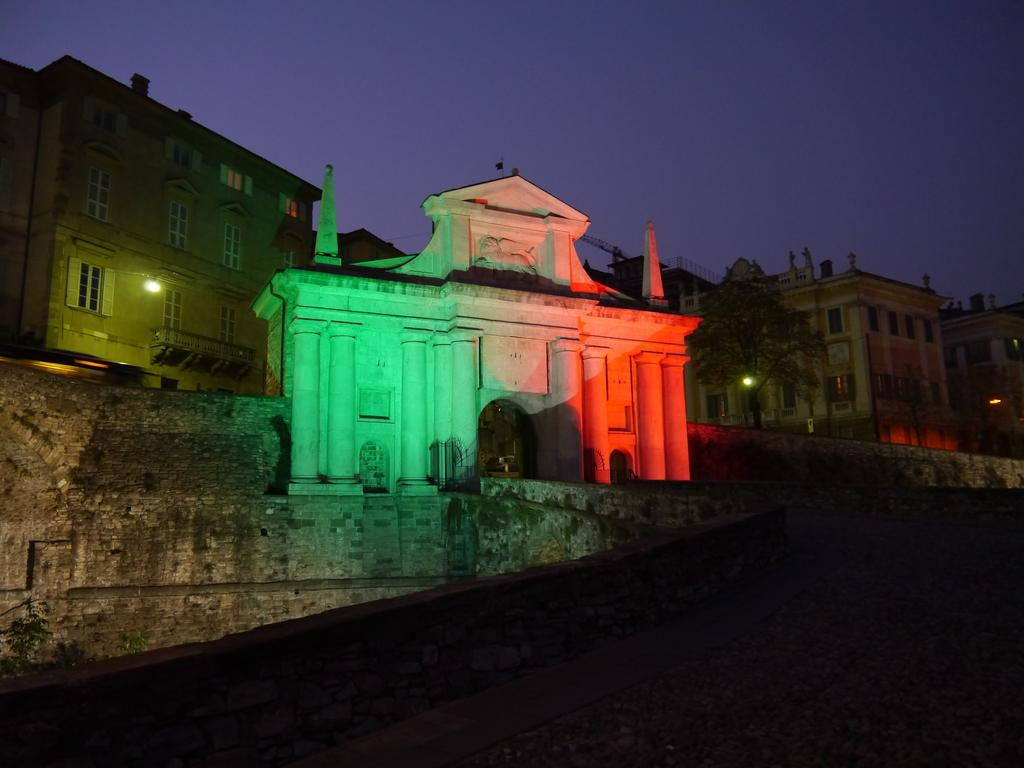What is located in the foreground of the image? There is a wall fence in the foreground of the image. What structures can be seen in the image? Buildings are visible in the image. What type of vegetation is present in the image? Trees are present in the image. Can you describe the lighting conditions in the image? There is light visible in the image. What architectural features can be seen in the image? Windows are observable in the image. What part of the natural environment is visible in the image? The sky is visible in the image. Based on the presence of light, can you determine the time of day the image was taken? The image may have been taken during the night, as there is light visible but the sky is not bright. What type of writing can be seen on the trees in the image? There is no writing visible on the trees in the image. What type of pleasure can be seen being experienced by the buildings in the image? Buildings do not experience pleasure, as they are inanimate objects. 